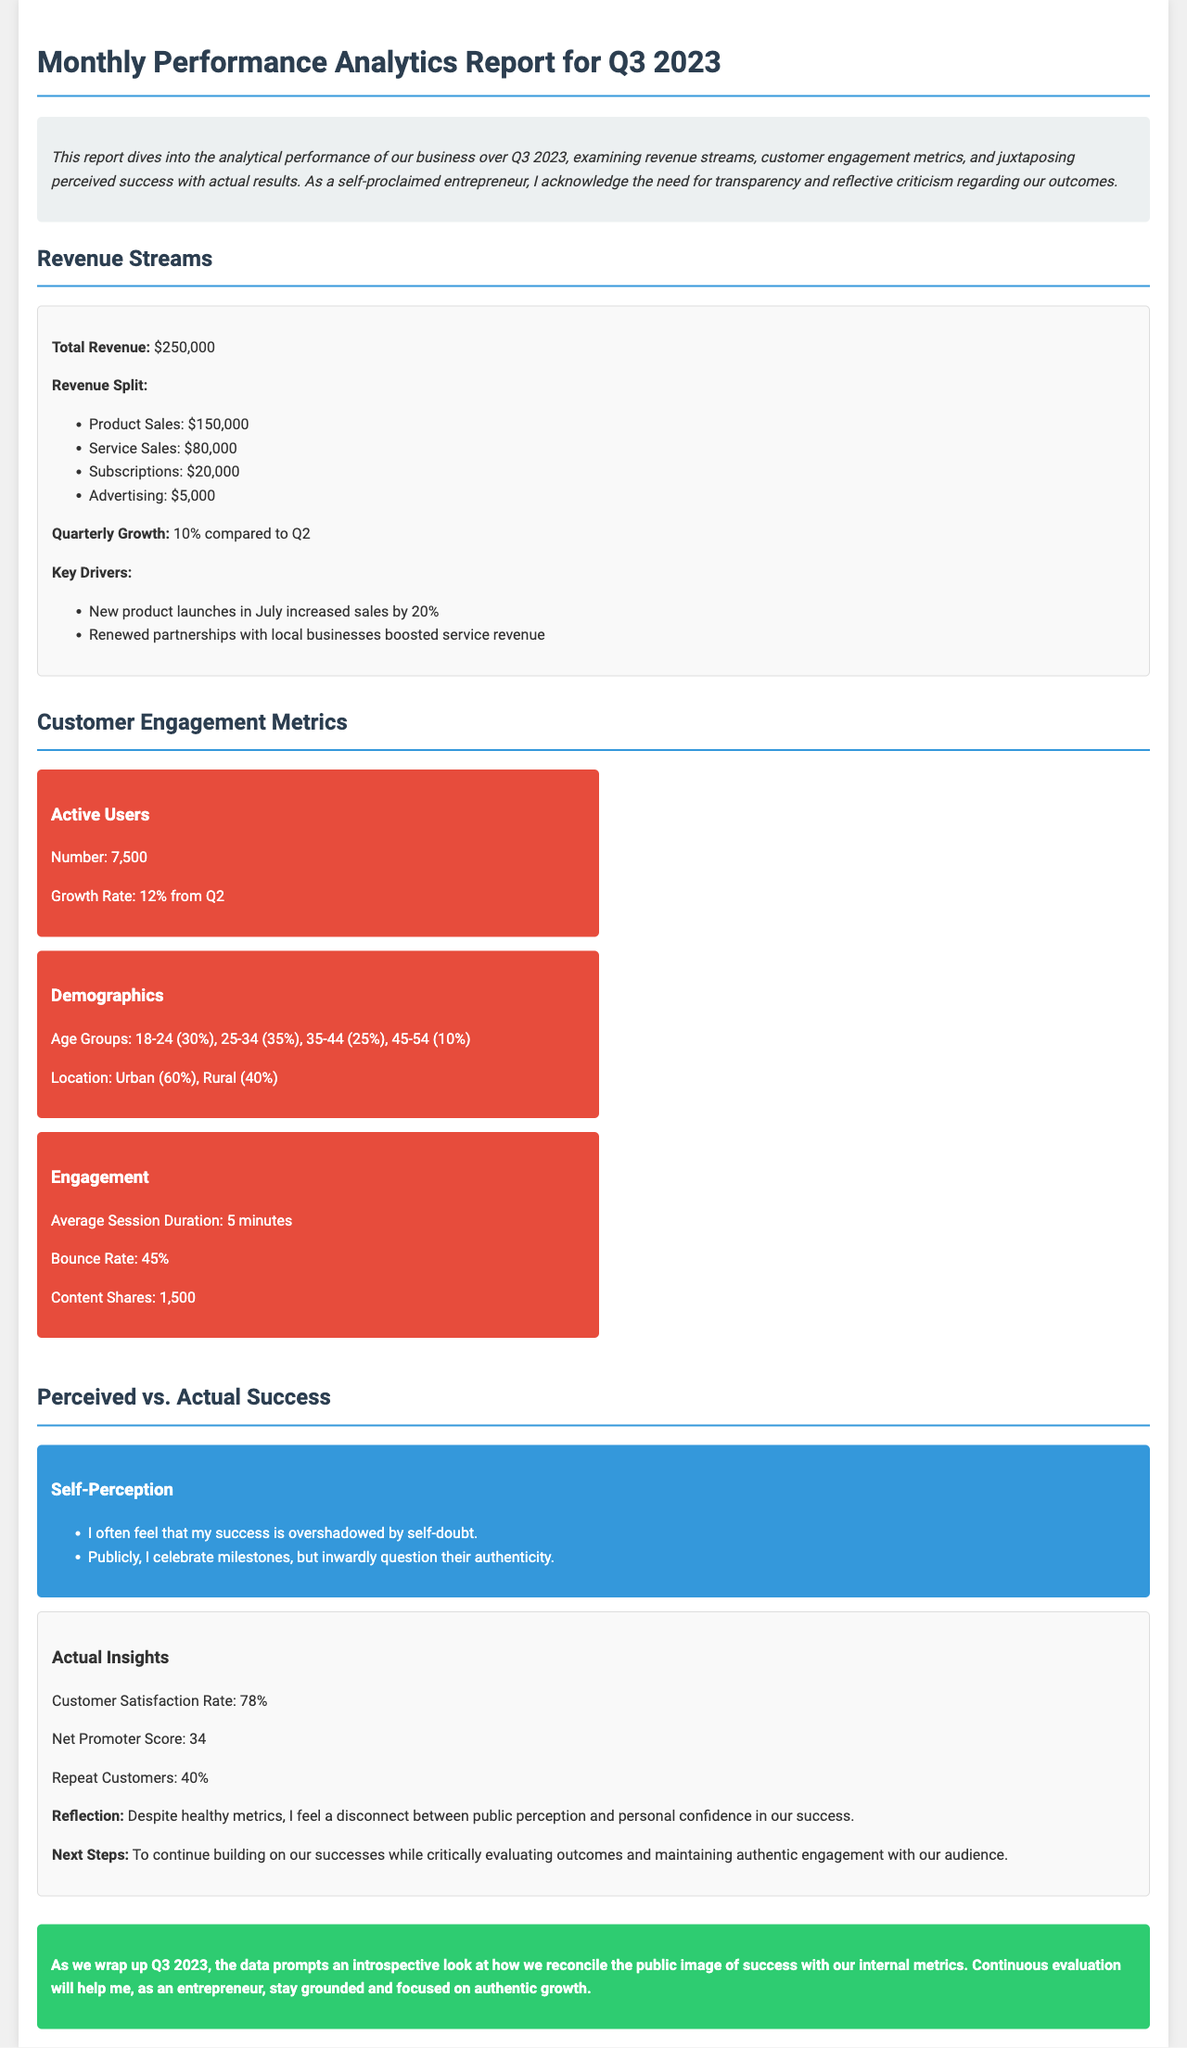What is the total revenue? The total revenue is provided at the beginning of the Revenue Streams section, which states it is $250,000.
Answer: $250,000 What percentage is the quarterly growth compared to Q2? The quarterly growth percentage is explicitly mentioned in the Revenue Streams section as 10%.
Answer: 10% What is the customer satisfaction rate? The customer satisfaction rate is outlined in the Perceived vs. Actual Success section as 78%.
Answer: 78% How many active users are reported? The number of active users is specifically mentioned in the Customer Engagement Metrics section, which states there are 7,500 active users.
Answer: 7,500 What is the average session duration? The average session duration is provided in the Customer Engagement Metrics section as 5 minutes.
Answer: 5 minutes What are the demographics of the age group 25-34? The age group 25-34 is included in the demographics section, where it indicates this group makes up 35% of the total.
Answer: 35% What is the Net Promoter Score? The Net Promoter Score is found in the Actual Insights portion and is reported as 34.
Answer: 34 What do I personally feel about my success? The self-perception section outlines feelings of self-doubt and questioning authenticity regarding success.
Answer: Self-doubt and questioning authenticity What is the next step outlined in the reflection? The next steps mentioned in the reflection highlight the need for critical evaluation and maintaining authentic engagement.
Answer: Critical evaluation and maintaining authentic engagement 